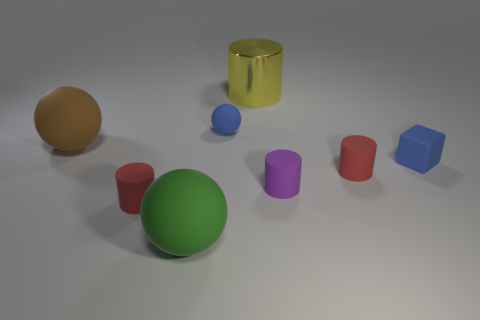What does the lighting tell us about the setting? The lighting in the image is soft and diffused, suggesting an indoor setting with ambient light, potentially from overhead sources. The shadows are gentle and short, indicating that the light source is neither too harsh nor too close to the objects, giving the scene a calm and balanced atmosphere. 